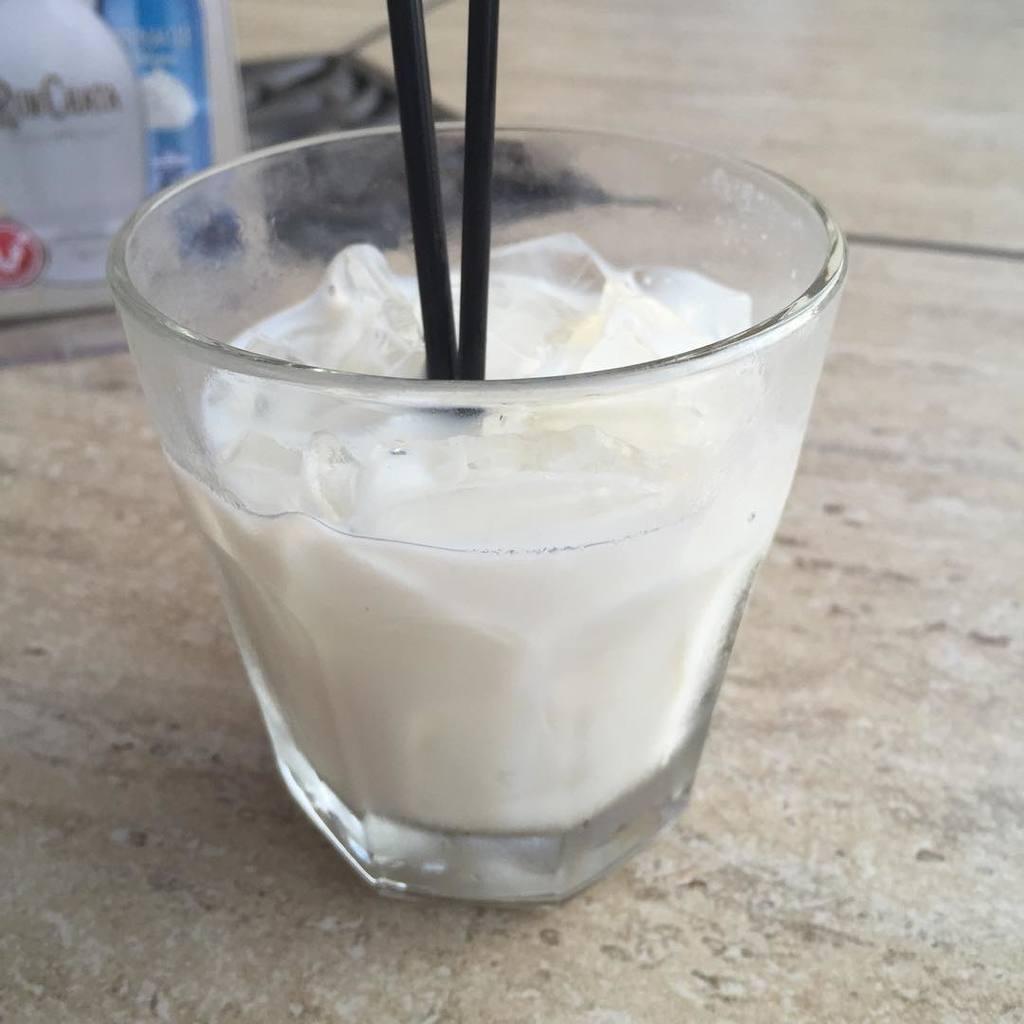Can you describe this image briefly? In the center of the image we can see milkshake is present in glass with straws. In the background of the image we can see boards, floor are there. 